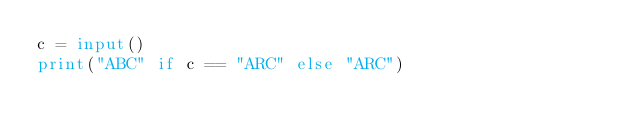Convert code to text. <code><loc_0><loc_0><loc_500><loc_500><_Python_>c = input()
print("ABC" if c == "ARC" else "ARC")</code> 